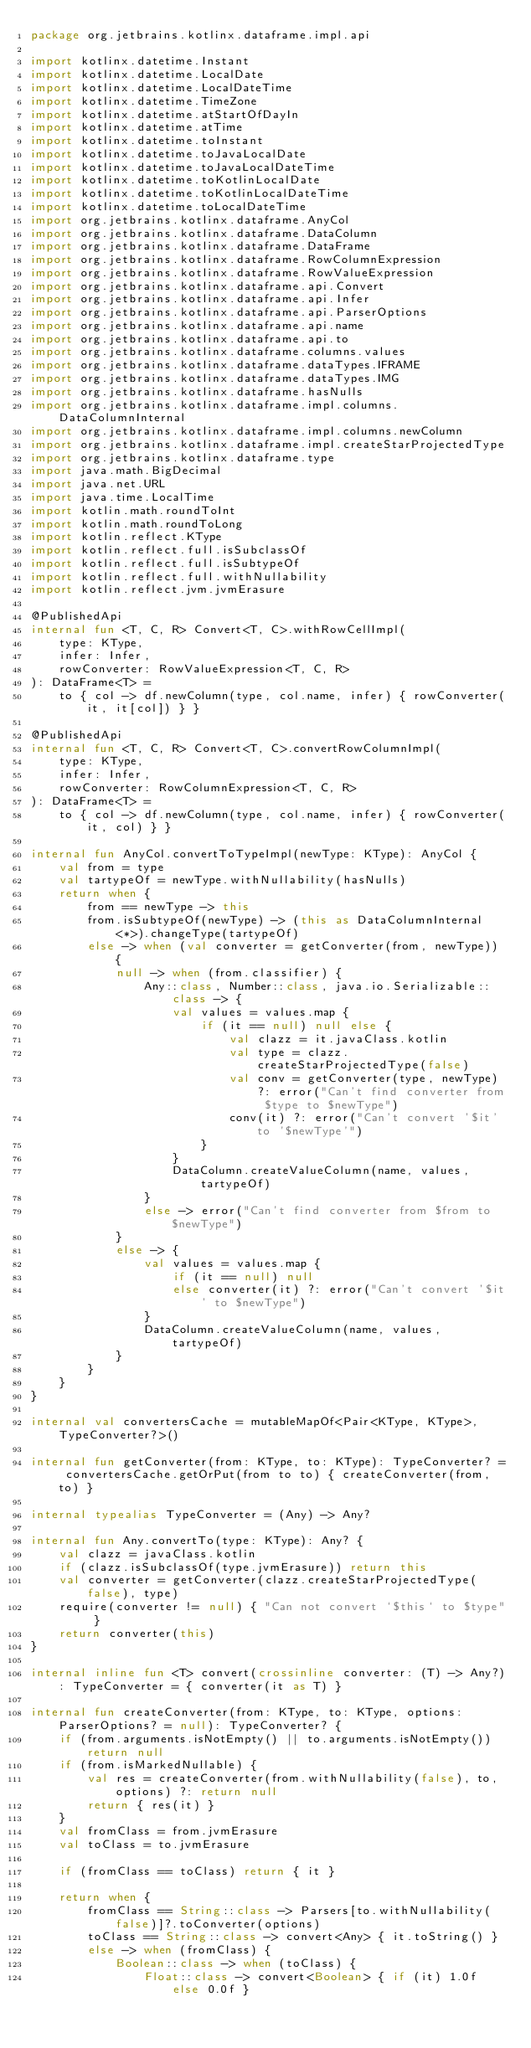<code> <loc_0><loc_0><loc_500><loc_500><_Kotlin_>package org.jetbrains.kotlinx.dataframe.impl.api

import kotlinx.datetime.Instant
import kotlinx.datetime.LocalDate
import kotlinx.datetime.LocalDateTime
import kotlinx.datetime.TimeZone
import kotlinx.datetime.atStartOfDayIn
import kotlinx.datetime.atTime
import kotlinx.datetime.toInstant
import kotlinx.datetime.toJavaLocalDate
import kotlinx.datetime.toJavaLocalDateTime
import kotlinx.datetime.toKotlinLocalDate
import kotlinx.datetime.toKotlinLocalDateTime
import kotlinx.datetime.toLocalDateTime
import org.jetbrains.kotlinx.dataframe.AnyCol
import org.jetbrains.kotlinx.dataframe.DataColumn
import org.jetbrains.kotlinx.dataframe.DataFrame
import org.jetbrains.kotlinx.dataframe.RowColumnExpression
import org.jetbrains.kotlinx.dataframe.RowValueExpression
import org.jetbrains.kotlinx.dataframe.api.Convert
import org.jetbrains.kotlinx.dataframe.api.Infer
import org.jetbrains.kotlinx.dataframe.api.ParserOptions
import org.jetbrains.kotlinx.dataframe.api.name
import org.jetbrains.kotlinx.dataframe.api.to
import org.jetbrains.kotlinx.dataframe.columns.values
import org.jetbrains.kotlinx.dataframe.dataTypes.IFRAME
import org.jetbrains.kotlinx.dataframe.dataTypes.IMG
import org.jetbrains.kotlinx.dataframe.hasNulls
import org.jetbrains.kotlinx.dataframe.impl.columns.DataColumnInternal
import org.jetbrains.kotlinx.dataframe.impl.columns.newColumn
import org.jetbrains.kotlinx.dataframe.impl.createStarProjectedType
import org.jetbrains.kotlinx.dataframe.type
import java.math.BigDecimal
import java.net.URL
import java.time.LocalTime
import kotlin.math.roundToInt
import kotlin.math.roundToLong
import kotlin.reflect.KType
import kotlin.reflect.full.isSubclassOf
import kotlin.reflect.full.isSubtypeOf
import kotlin.reflect.full.withNullability
import kotlin.reflect.jvm.jvmErasure

@PublishedApi
internal fun <T, C, R> Convert<T, C>.withRowCellImpl(
    type: KType,
    infer: Infer,
    rowConverter: RowValueExpression<T, C, R>
): DataFrame<T> =
    to { col -> df.newColumn(type, col.name, infer) { rowConverter(it, it[col]) } }

@PublishedApi
internal fun <T, C, R> Convert<T, C>.convertRowColumnImpl(
    type: KType,
    infer: Infer,
    rowConverter: RowColumnExpression<T, C, R>
): DataFrame<T> =
    to { col -> df.newColumn(type, col.name, infer) { rowConverter(it, col) } }

internal fun AnyCol.convertToTypeImpl(newType: KType): AnyCol {
    val from = type
    val tartypeOf = newType.withNullability(hasNulls)
    return when {
        from == newType -> this
        from.isSubtypeOf(newType) -> (this as DataColumnInternal<*>).changeType(tartypeOf)
        else -> when (val converter = getConverter(from, newType)) {
            null -> when (from.classifier) {
                Any::class, Number::class, java.io.Serializable::class -> {
                    val values = values.map {
                        if (it == null) null else {
                            val clazz = it.javaClass.kotlin
                            val type = clazz.createStarProjectedType(false)
                            val conv = getConverter(type, newType) ?: error("Can't find converter from $type to $newType")
                            conv(it) ?: error("Can't convert '$it' to '$newType'")
                        }
                    }
                    DataColumn.createValueColumn(name, values, tartypeOf)
                }
                else -> error("Can't find converter from $from to $newType")
            }
            else -> {
                val values = values.map {
                    if (it == null) null
                    else converter(it) ?: error("Can't convert '$it' to $newType")
                }
                DataColumn.createValueColumn(name, values, tartypeOf)
            }
        }
    }
}

internal val convertersCache = mutableMapOf<Pair<KType, KType>, TypeConverter?>()

internal fun getConverter(from: KType, to: KType): TypeConverter? = convertersCache.getOrPut(from to to) { createConverter(from, to) }

internal typealias TypeConverter = (Any) -> Any?

internal fun Any.convertTo(type: KType): Any? {
    val clazz = javaClass.kotlin
    if (clazz.isSubclassOf(type.jvmErasure)) return this
    val converter = getConverter(clazz.createStarProjectedType(false), type)
    require(converter != null) { "Can not convert `$this` to $type" }
    return converter(this)
}

internal inline fun <T> convert(crossinline converter: (T) -> Any?): TypeConverter = { converter(it as T) }

internal fun createConverter(from: KType, to: KType, options: ParserOptions? = null): TypeConverter? {
    if (from.arguments.isNotEmpty() || to.arguments.isNotEmpty()) return null
    if (from.isMarkedNullable) {
        val res = createConverter(from.withNullability(false), to, options) ?: return null
        return { res(it) }
    }
    val fromClass = from.jvmErasure
    val toClass = to.jvmErasure

    if (fromClass == toClass) return { it }

    return when {
        fromClass == String::class -> Parsers[to.withNullability(false)]?.toConverter(options)
        toClass == String::class -> convert<Any> { it.toString() }
        else -> when (fromClass) {
            Boolean::class -> when (toClass) {
                Float::class -> convert<Boolean> { if (it) 1.0f else 0.0f }</code> 